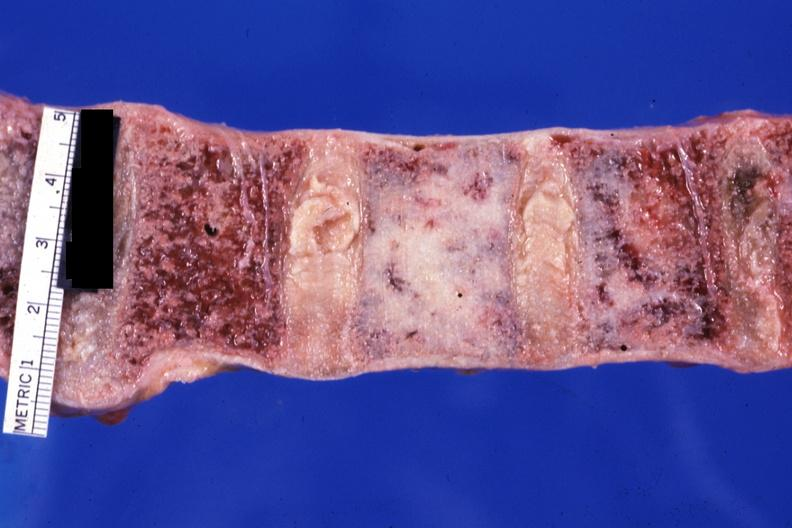does close-up look like ivory vertebra of breast carcinoma?
Answer the question using a single word or phrase. Yes 